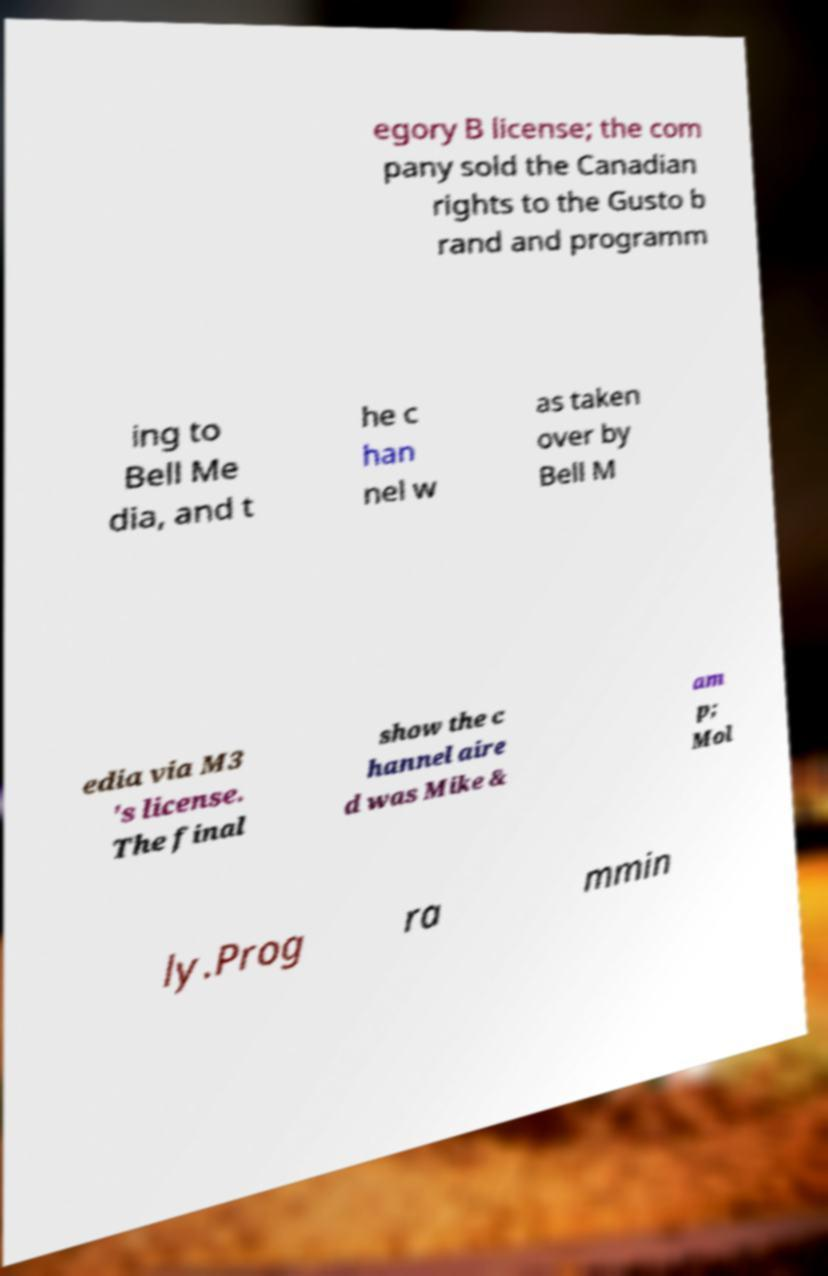Could you extract and type out the text from this image? egory B license; the com pany sold the Canadian rights to the Gusto b rand and programm ing to Bell Me dia, and t he c han nel w as taken over by Bell M edia via M3 's license. The final show the c hannel aire d was Mike & am p; Mol ly.Prog ra mmin 